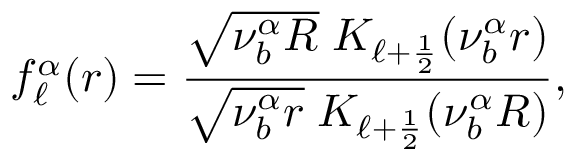<formula> <loc_0><loc_0><loc_500><loc_500>f _ { \ell } ^ { \alpha } ( r ) = \frac { \sqrt { \nu _ { b } ^ { \alpha } R } \, K _ { \ell + \frac { 1 } { 2 } } ( \nu _ { b } ^ { \alpha } r ) } { \sqrt { \nu _ { b } ^ { \alpha } r } \, K _ { \ell + \frac { 1 } { 2 } } ( \nu _ { b } ^ { \alpha } R ) } ,</formula> 